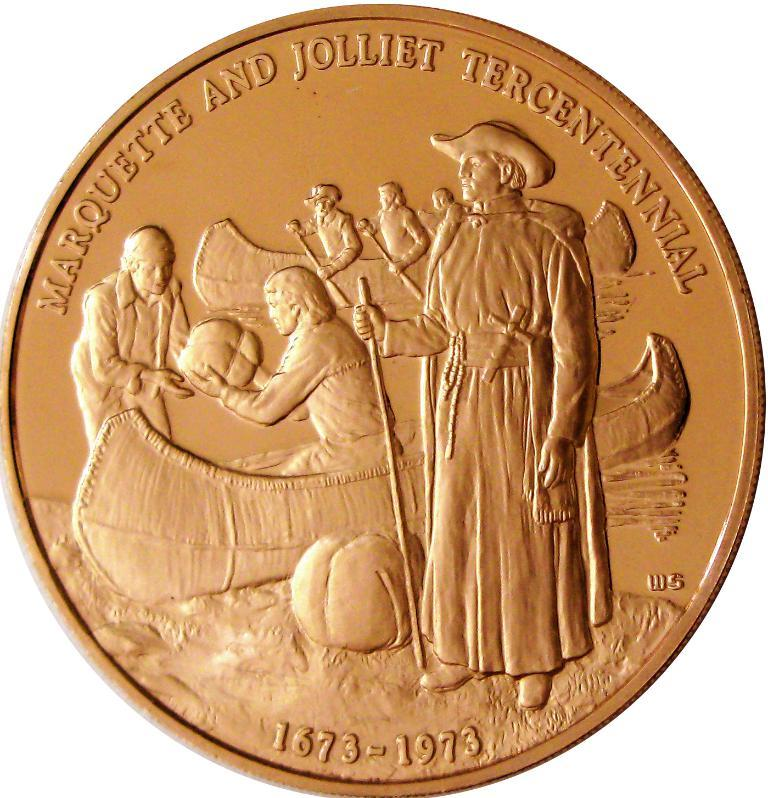<image>
Create a compact narrative representing the image presented. A coin that shows the years 1673-1973 on it. 